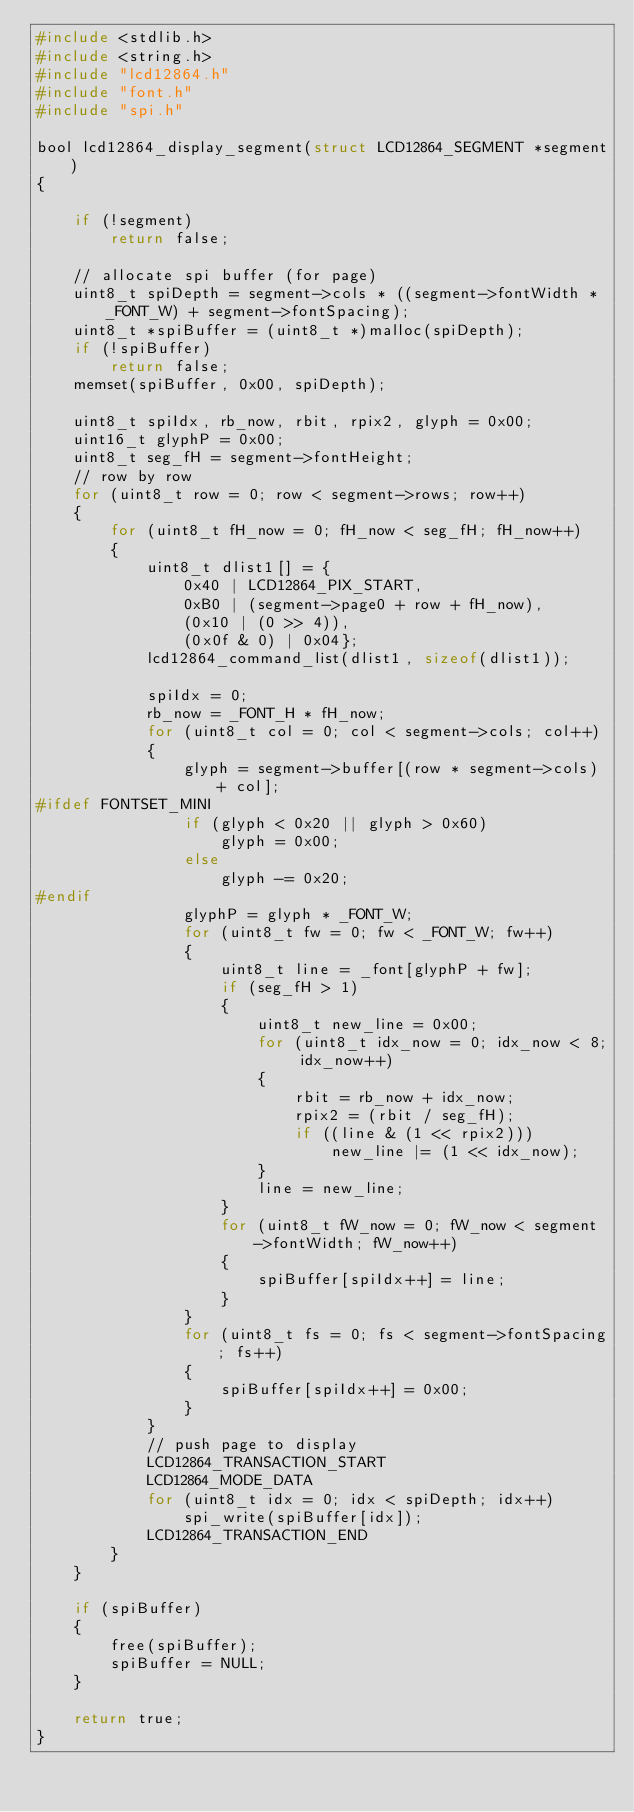Convert code to text. <code><loc_0><loc_0><loc_500><loc_500><_C_>#include <stdlib.h>
#include <string.h>
#include "lcd12864.h"
#include "font.h"
#include "spi.h"

bool lcd12864_display_segment(struct LCD12864_SEGMENT *segment)
{

    if (!segment)
        return false;

    // allocate spi buffer (for page)
    uint8_t spiDepth = segment->cols * ((segment->fontWidth * _FONT_W) + segment->fontSpacing);
    uint8_t *spiBuffer = (uint8_t *)malloc(spiDepth);
    if (!spiBuffer)
        return false;
    memset(spiBuffer, 0x00, spiDepth);

    uint8_t spiIdx, rb_now, rbit, rpix2, glyph = 0x00;
    uint16_t glyphP = 0x00;
    uint8_t seg_fH = segment->fontHeight;
    // row by row
    for (uint8_t row = 0; row < segment->rows; row++)
    {
        for (uint8_t fH_now = 0; fH_now < seg_fH; fH_now++)
        {
            uint8_t dlist1[] = {
                0x40 | LCD12864_PIX_START,
                0xB0 | (segment->page0 + row + fH_now),
                (0x10 | (0 >> 4)),
                (0x0f & 0) | 0x04};
            lcd12864_command_list(dlist1, sizeof(dlist1));
 
            spiIdx = 0;
            rb_now = _FONT_H * fH_now;
            for (uint8_t col = 0; col < segment->cols; col++)
            {
                glyph = segment->buffer[(row * segment->cols) + col];
#ifdef FONTSET_MINI
                if (glyph < 0x20 || glyph > 0x60)
                    glyph = 0x00;
                else
                    glyph -= 0x20;
#endif
                glyphP = glyph * _FONT_W;
                for (uint8_t fw = 0; fw < _FONT_W; fw++)
                {
                    uint8_t line = _font[glyphP + fw];
                    if (seg_fH > 1)
                    {
                        uint8_t new_line = 0x00;
                        for (uint8_t idx_now = 0; idx_now < 8; idx_now++)
                        {
                            rbit = rb_now + idx_now;
                            rpix2 = (rbit / seg_fH);
                            if ((line & (1 << rpix2)))
                                new_line |= (1 << idx_now);
                        }
                        line = new_line;
                    }
                    for (uint8_t fW_now = 0; fW_now < segment->fontWidth; fW_now++)
                    {
                        spiBuffer[spiIdx++] = line;
                    }
                }
                for (uint8_t fs = 0; fs < segment->fontSpacing; fs++)
                {
                    spiBuffer[spiIdx++] = 0x00;
                }
            }
            // push page to display
            LCD12864_TRANSACTION_START
            LCD12864_MODE_DATA
            for (uint8_t idx = 0; idx < spiDepth; idx++)
                spi_write(spiBuffer[idx]);
            LCD12864_TRANSACTION_END
        }
    }

    if (spiBuffer)
    {
        free(spiBuffer);
        spiBuffer = NULL;
    }

    return true;
}</code> 